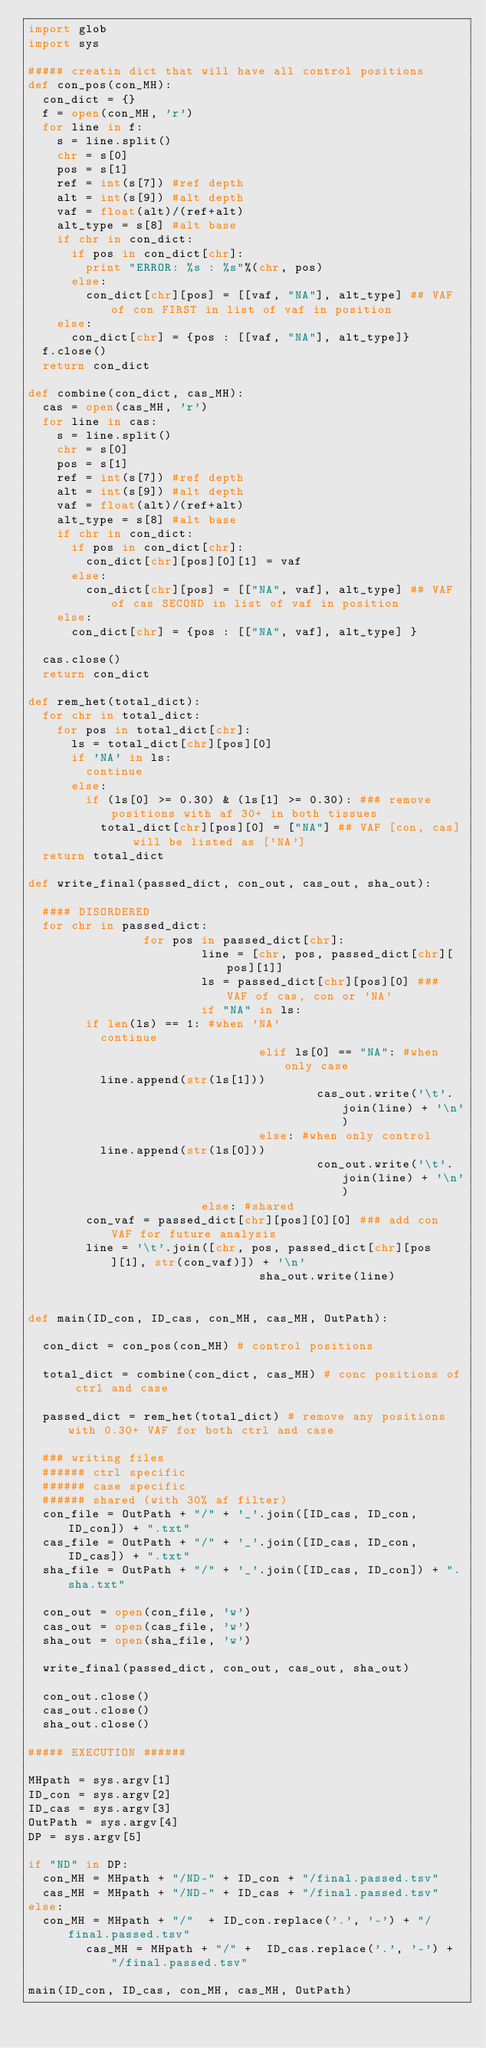Convert code to text. <code><loc_0><loc_0><loc_500><loc_500><_Python_>import glob
import sys

##### creatin dict that will have all control positions
def con_pos(con_MH):
	con_dict = {}		
	f = open(con_MH, 'r')
	for line in f:
		s = line.split()
		chr = s[0]
		pos = s[1]	
		ref = int(s[7]) #ref depth
		alt = int(s[9]) #alt depth
		vaf = float(alt)/(ref+alt)
		alt_type = s[8] #alt base
		if chr in con_dict:
			if pos in con_dict[chr]:
				print "ERROR: %s : %s"%(chr, pos)
			else:
				con_dict[chr][pos] = [[vaf, "NA"], alt_type] ## VAF of con FIRST in list of vaf in position
		else:
			con_dict[chr] = {pos : [[vaf, "NA"], alt_type]}
	f.close()
	return con_dict

def combine(con_dict, cas_MH):
	cas = open(cas_MH, 'r')
	for line in cas:
		s = line.split()
		chr = s[0]
		pos = s[1] 
		ref = int(s[7]) #ref depth
		alt = int(s[9]) #alt depth
		vaf = float(alt)/(ref+alt)
		alt_type = s[8] #alt base
		if chr in con_dict:
			if pos in con_dict[chr]:
				con_dict[chr][pos][0][1] = vaf
			else:	
				con_dict[chr][pos] = [["NA", vaf], alt_type] ## VAF of cas SECOND in list of vaf in position
		else:
			con_dict[chr] = {pos : [["NA", vaf], alt_type] } 

	cas.close()	
	return con_dict	

def rem_het(total_dict):
	for chr in total_dict:
		for pos in total_dict[chr]:
			ls = total_dict[chr][pos][0]
			if 'NA' in ls:
				continue
			else:
				if (ls[0] >= 0.30) & (ls[1] >= 0.30): ### remove positions with af 30+ in both tissues
					total_dict[chr][pos][0] = ["NA"] ## VAF [con, cas] will be listed as ['NA']
	return total_dict

def write_final(passed_dict, con_out, cas_out, sha_out):
	
	#### DISORDERED
	for chr in passed_dict:
                for pos in passed_dict[chr]:
                        line = [chr, pos, passed_dict[chr][pos][1]]
                        ls = passed_dict[chr][pos][0] ### VAF of cas, con or 'NA'
                        if "NA" in ls:
				if len(ls) == 1: #when 'NA'
					continue
                                elif ls[0] == "NA": #when only case
					line.append(str(ls[1]))
                                        cas_out.write('\t'.join(line) + '\n')
                                else: #when only control
					line.append(str(ls[0]))
                                        con_out.write('\t'.join(line) + '\n')
                        else: #shared
				con_vaf = passed_dict[chr][pos][0][0] ### add con VAF for future analysis
				line = '\t'.join([chr, pos, passed_dict[chr][pos][1], str(con_vaf)]) + '\n' 
                                sha_out.write(line)	

		
def main(ID_con, ID_cas, con_MH, cas_MH, OutPath):	
	
	con_dict = con_pos(con_MH) # control positions
	
	total_dict = combine(con_dict, cas_MH) # conc positions of ctrl and case
 
	passed_dict = rem_het(total_dict) # remove any positions with 0.30+ VAF for both ctrl and case
	
	### writing files
	###### ctrl specific
	###### case specific
	###### shared (with 30% af filter)
	con_file = OutPath + "/" + '_'.join([ID_cas, ID_con, ID_con]) + ".txt"
	cas_file = OutPath + "/" + '_'.join([ID_cas, ID_con, ID_cas]) + ".txt"
	sha_file = OutPath + "/" + '_'.join([ID_cas, ID_con]) + ".sha.txt"
		
	con_out = open(con_file, 'w')
	cas_out = open(cas_file, 'w')
	sha_out = open(sha_file, 'w')	

	write_final(passed_dict, con_out, cas_out, sha_out)

	con_out.close()
	cas_out.close()
	sha_out.close()

##### EXECUTION ######

MHpath = sys.argv[1]
ID_con = sys.argv[2]
ID_cas = sys.argv[3]
OutPath = sys.argv[4]
DP = sys.argv[5]

if "ND" in DP:
	con_MH = MHpath + "/ND-" + ID_con + "/final.passed.tsv"
	cas_MH = MHpath + "/ND-" + ID_cas + "/final.passed.tsv"
else:
	con_MH = MHpath + "/"  + ID_con.replace('.', '-') + "/final.passed.tsv"
        cas_MH = MHpath + "/" +  ID_cas.replace('.', '-') + "/final.passed.tsv"	

main(ID_con, ID_cas, con_MH, cas_MH, OutPath)
</code> 